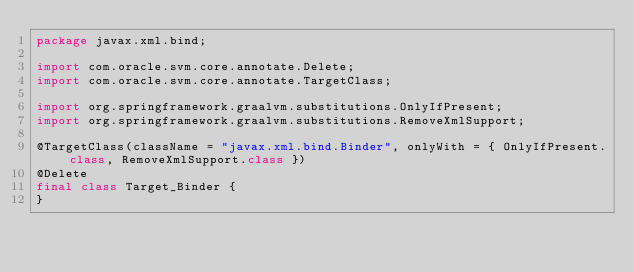Convert code to text. <code><loc_0><loc_0><loc_500><loc_500><_Java_>package javax.xml.bind;

import com.oracle.svm.core.annotate.Delete;
import com.oracle.svm.core.annotate.TargetClass;

import org.springframework.graalvm.substitutions.OnlyIfPresent;
import org.springframework.graalvm.substitutions.RemoveXmlSupport;

@TargetClass(className = "javax.xml.bind.Binder", onlyWith = { OnlyIfPresent.class, RemoveXmlSupport.class })
@Delete
final class Target_Binder {
}
</code> 